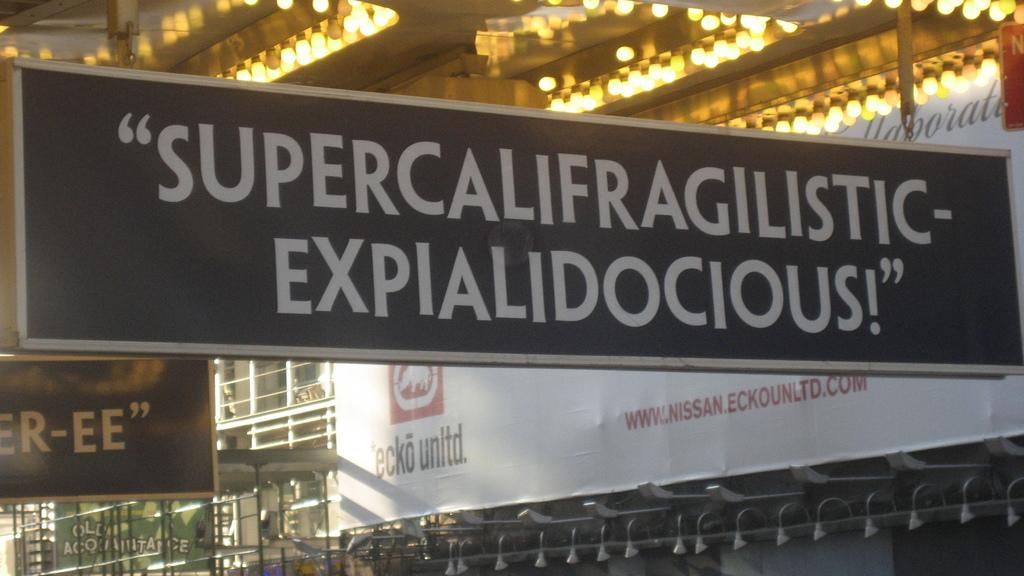What is the main subject of the image? The main subject of the image is a building. What additional elements can be seen in the image? There are hoardings and banners in the image. Are there any lighting features in the image? Yes, there are lights in the image. How many cats can be seen sitting on the furniture in the image? There are no cats or furniture present in the image. What time is indicated by the clock in the image? There is no clock present in the image. 